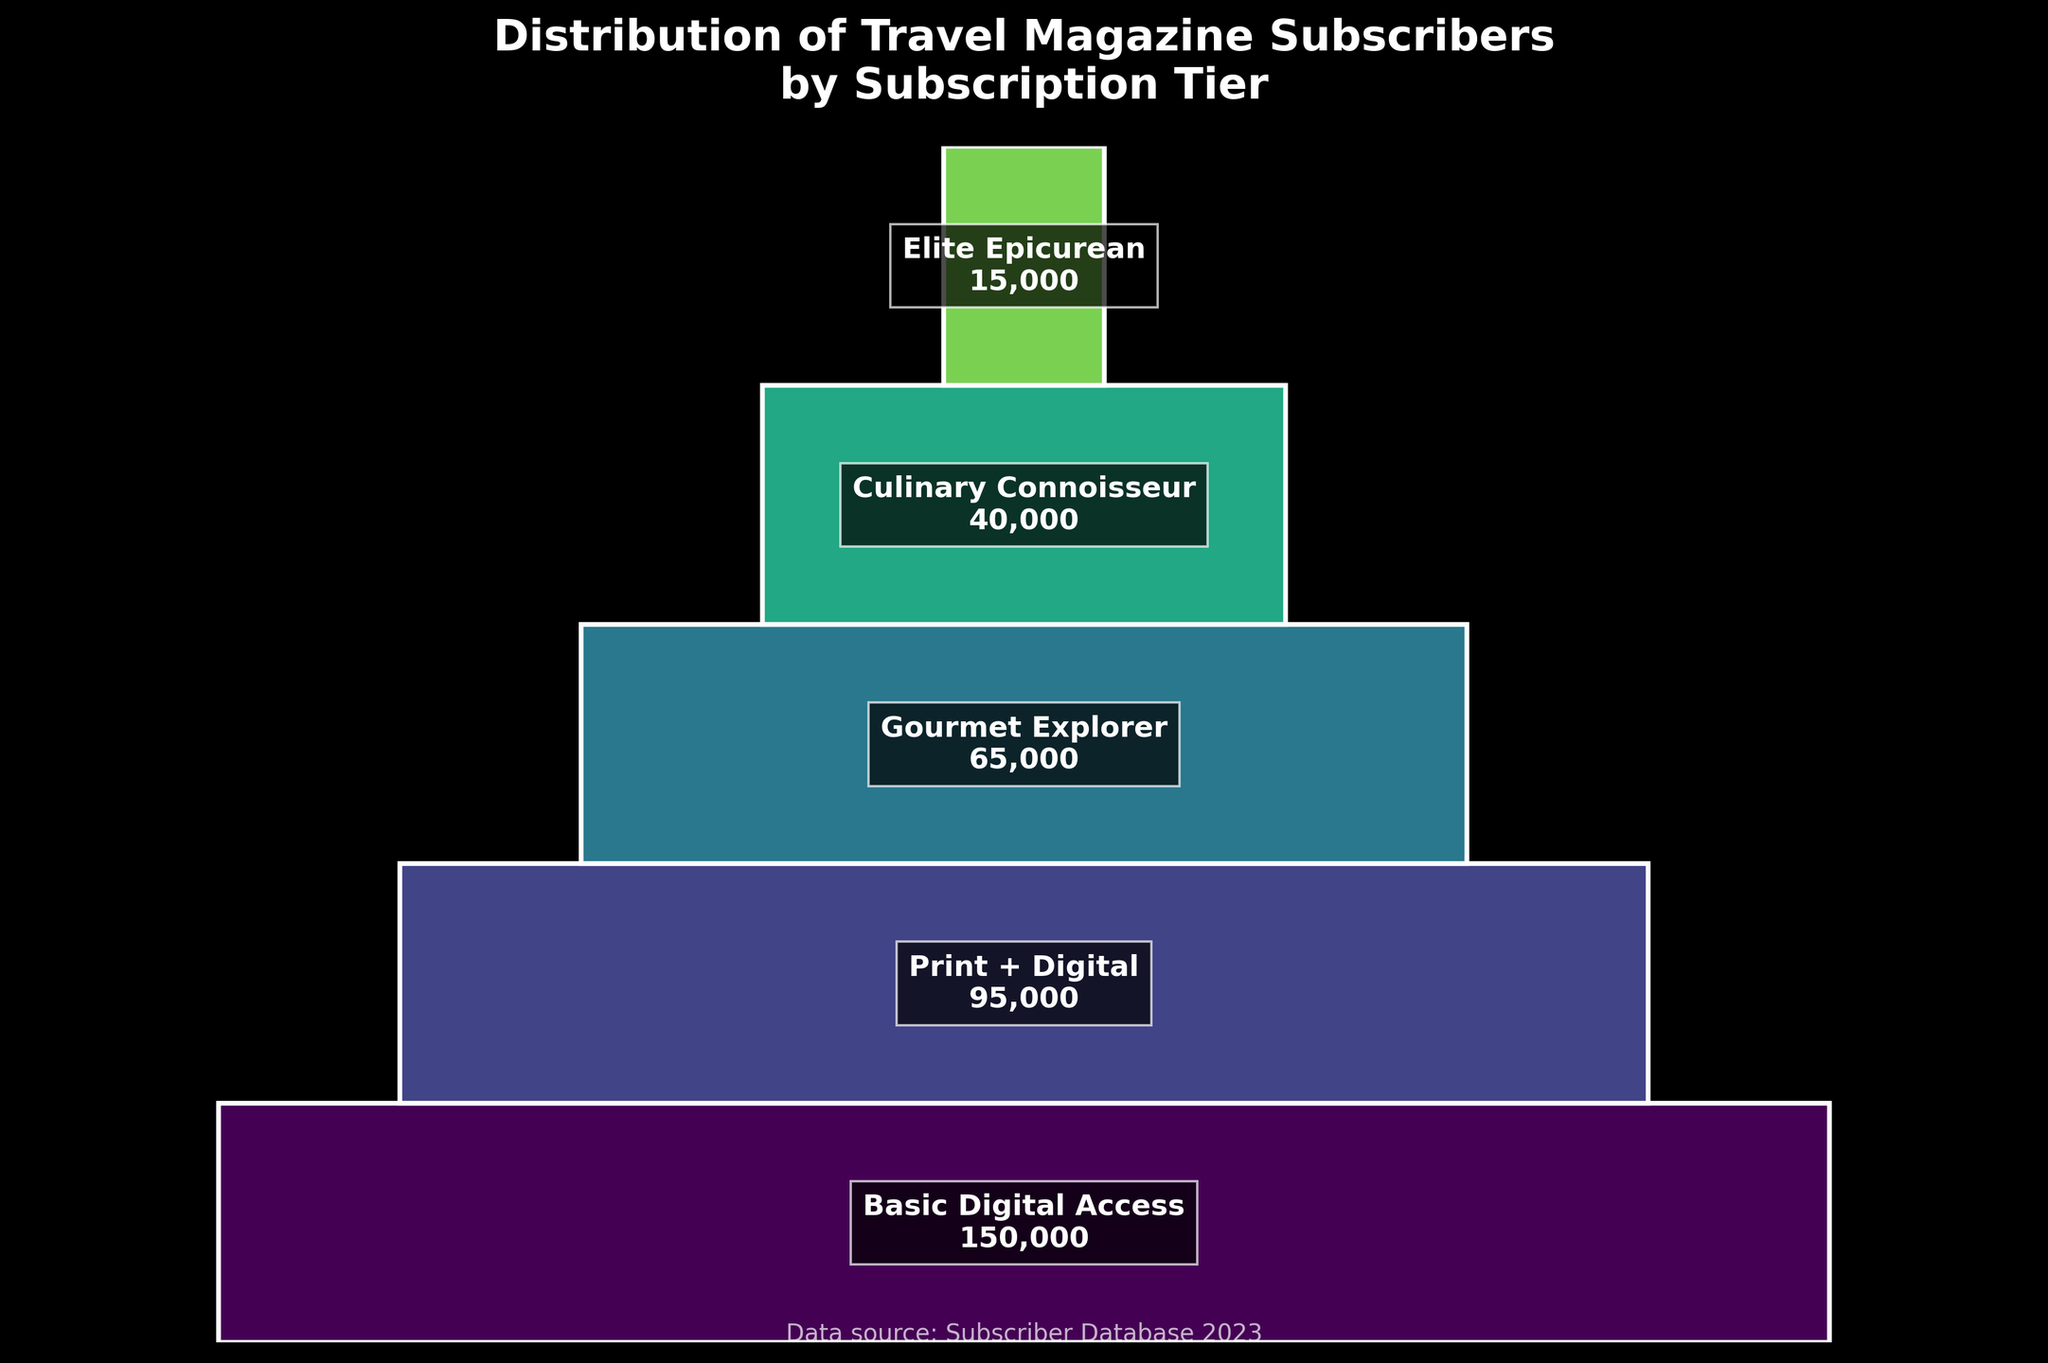What is the title of the figure? The title can be found at the top of the chart. It reads "Distribution of Travel Magazine Subscribers by Subscription Tier."
Answer: Distribution of Travel Magazine Subscribers by Subscription Tier How many subscription tiers are shown in the figure? Each subscription tier is represented by a segment in the funnel chart. By counting these segments, we can tell the number of tiers.
Answer: 5 Which subscription tier has the highest number of subscribers? The top segment of the funnel chart represents the tier with the highest number of subscribers. It is labeled "Basic Digital Access" with 150,000 subscribers.
Answer: Basic Digital Access What is the total number of subscribers for all tiers combined? To find the total, sum the number of subscribers for each tier displayed: 150,000 + 95,000 + 65,000 + 40,000 + 15,000. The sum of these numbers is 365,000.
Answer: 365,000 How many tiers have more than 50,000 subscribers? Check each tier's subscriber count. The "Basic Digital Access," "Print + Digital," and "Gourmet Explorer" tiers each have more than 50,000 subscribers.
Answer: 3 What is the difference in the number of subscribers between the "Basic Digital Access" and the "Elite Epicurean" tiers? Subtract the number of subscribers of the "Elite Epicurean" tier from the "Basic Digital Access" tier: 150,000 - 15,000. The result is 135,000.
Answer: 135,000 Which tier experienced the largest drop in subscribers compared to the previous tier? To determine this, we need to calculate the difference between consecutive tiers. 
1. Basic Digital Access to Print + Digital: 150,000 - 95,000 = 55,000
2. Print + Digital to Gourmet Explorer: 95,000 - 65,000 = 30,000
3. Gourmet Explorer to Culinary Connoisseur: 65,000 - 40,000 = 25,000
4. Culinary Connoisseur to Elite Epicurean: 40,000 - 15,000 = 25,000
The largest drop is between "Basic Digital Access" and "Print + Digital," with a difference of 55,000.
Answer: Basic Digital Access to Print + Digital What is the average number of subscribers per tier? Divide the total number of subscribers by the number of tiers: 365,000/5. This gives an average of 73,000.
Answer: 73,000 What percentage of the total subscribers is represented by the "Culinary Connoisseur" tier? Divide the subscribers of the "Culinary Connoisseur" tier by the total number of subscribers, then multiply by 100: (40,000/365,000) * 100. This equates to approximately 10.96%.
Answer: 10.96% What is the combined percentage of subscribers in the "Gourmet Explorer" and "Culinary Connoisseur" tiers? First, calculate the total for both tiers, which is 65,000 + 40,000 = 105,000. Then divide by the total number of subscribers and multiply by 100: (105,000/365,000) * 100. This equals approximately 28.77%.
Answer: 28.77% 